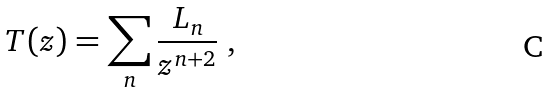<formula> <loc_0><loc_0><loc_500><loc_500>T ( z ) = \sum _ { n } { \frac { L _ { n } } { z ^ { n + 2 } } } \ ,</formula> 